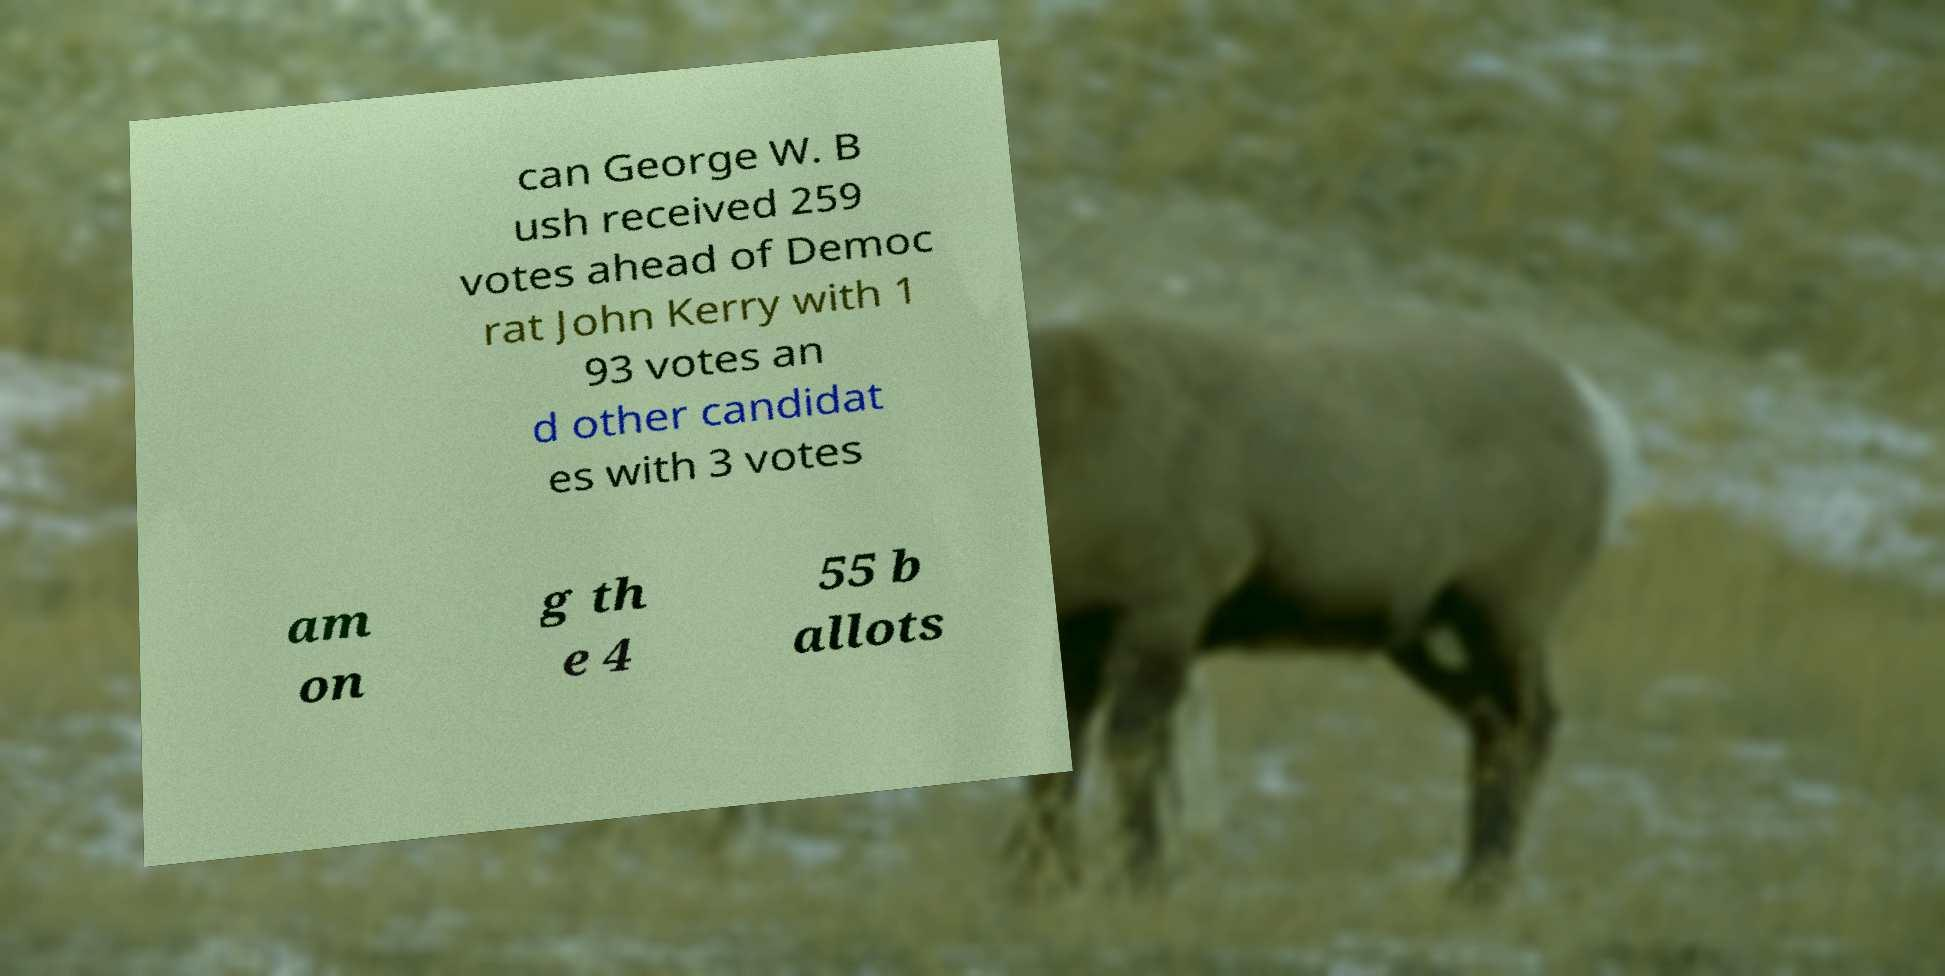Please identify and transcribe the text found in this image. can George W. B ush received 259 votes ahead of Democ rat John Kerry with 1 93 votes an d other candidat es with 3 votes am on g th e 4 55 b allots 